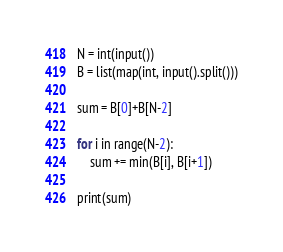<code> <loc_0><loc_0><loc_500><loc_500><_Python_>N = int(input())
B = list(map(int, input().split()))

sum = B[0]+B[N-2]

for i in range(N-2):
    sum += min(B[i], B[i+1])

print(sum)</code> 